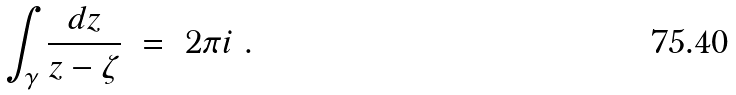<formula> <loc_0><loc_0><loc_500><loc_500>\int _ { \gamma } \frac { d z } { z - \zeta } \ = \ 2 \pi i \ .</formula> 